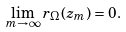Convert formula to latex. <formula><loc_0><loc_0><loc_500><loc_500>\lim _ { m \rightarrow \infty } r _ { \Omega } ( z _ { m } ) = 0 .</formula> 